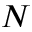<formula> <loc_0><loc_0><loc_500><loc_500>N</formula> 